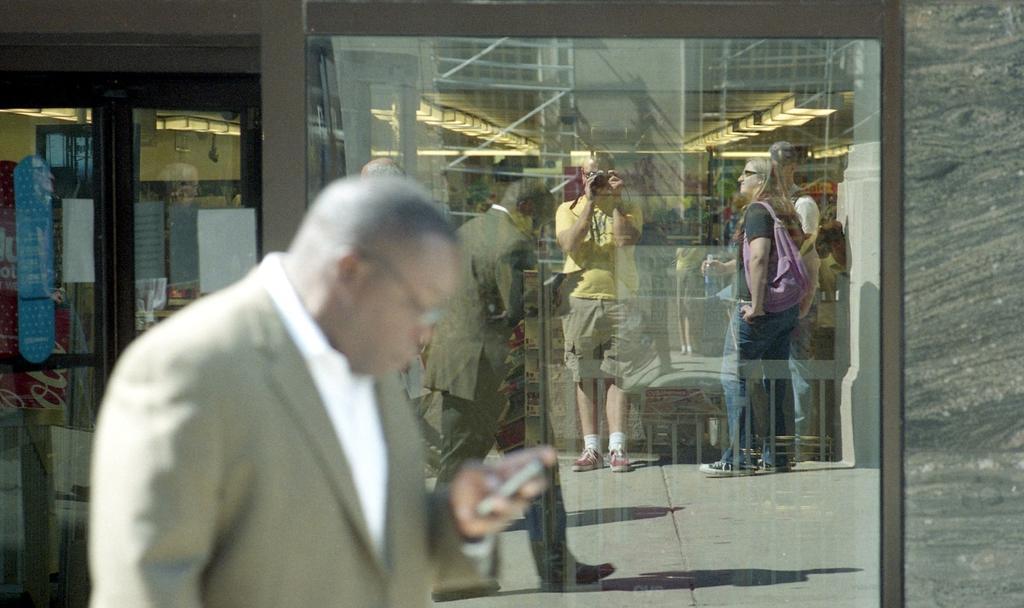Describe this image in one or two sentences. In this image there is a man, in the background there is a glass door, on that door there are few persons visible. 